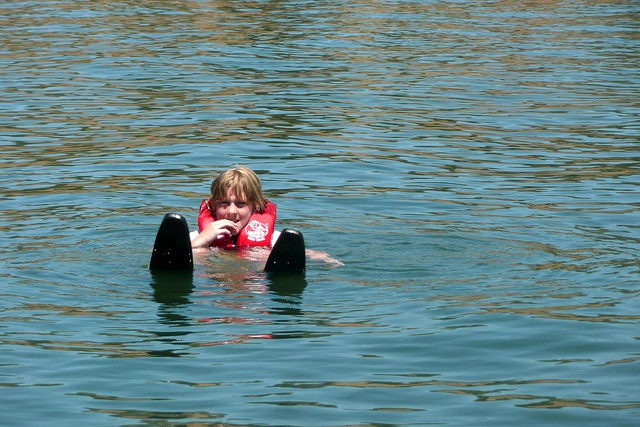Describe the objects in this image and their specific colors. I can see people in gray, maroon, white, brown, and lightpink tones and skis in gray, black, darkgray, and teal tones in this image. 